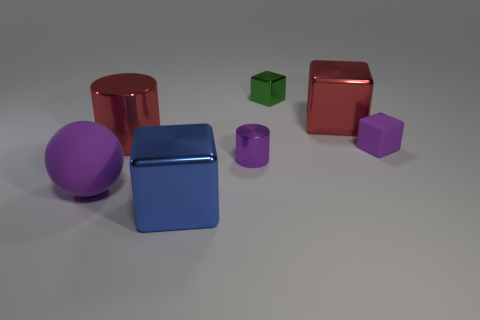Add 1 large metallic cylinders. How many objects exist? 8 Subtract all big red blocks. How many blocks are left? 3 Subtract all cylinders. How many objects are left? 5 Subtract all yellow balls. How many green cubes are left? 1 Subtract all balls. Subtract all tiny shiny things. How many objects are left? 4 Add 7 tiny green blocks. How many tiny green blocks are left? 8 Add 5 red metallic blocks. How many red metallic blocks exist? 6 Subtract all purple cubes. How many cubes are left? 3 Subtract 0 blue cylinders. How many objects are left? 7 Subtract 1 spheres. How many spheres are left? 0 